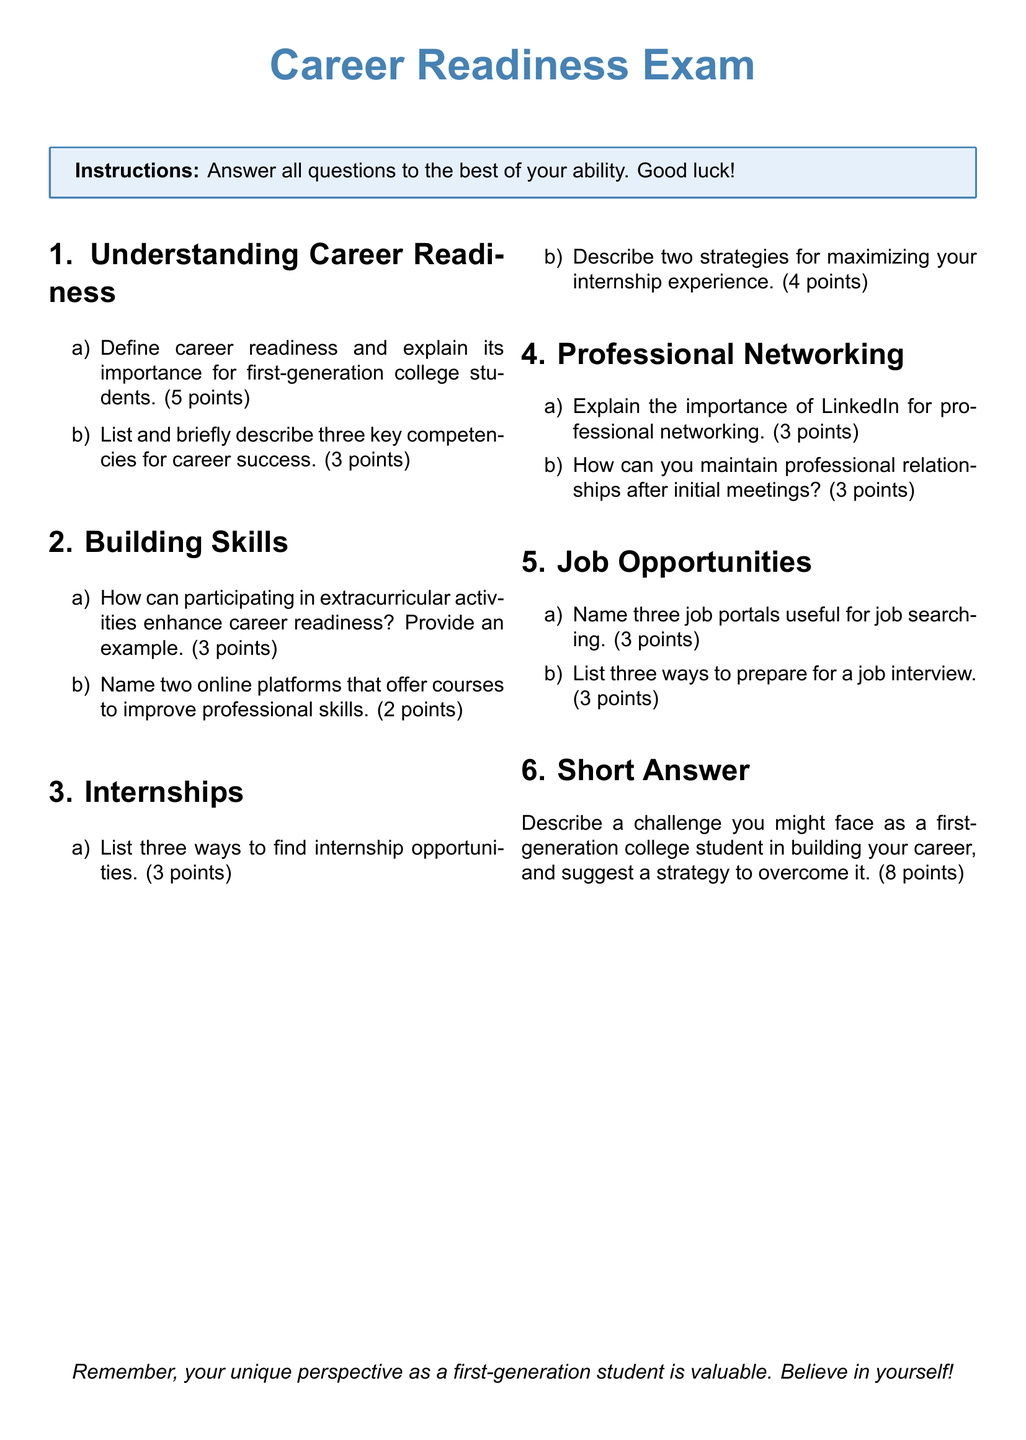what is the title of the exam? The title of the exam is specified at the top of the document, clearly stated.
Answer: Career Readiness Exam how many points is the first question worth? The document specifies the point value allocated for the first question in the first section.
Answer: 5 points name two online platforms mentioned for skill improvement. The document lists two specific online platforms in the section about building skills.
Answer: (no specific platforms listed) what is one example of an extracurricular activity that enhances career readiness? The answer should provide a relevant example mentioned in the document highlighting the link between extracurricular activities and career readiness.
Answer: (no specific activity listed) how many job portals are suggested for job searching? The document indicates the number of job portals listed in the section about job opportunities.
Answer: 3 what is the total number of sections in this exam? The number of distinct sections is outlined in the structure of the document, shown by the headings.
Answer: 6 what is the required response format for the last question? The document specifies how to respond to the last question about challenges faced as a first-generation student.
Answer: Short Answer what is the color scheme used for the box around instructions? The document describes the color used for the box surrounding the instructions for the exam.
Answer: mylightblue 